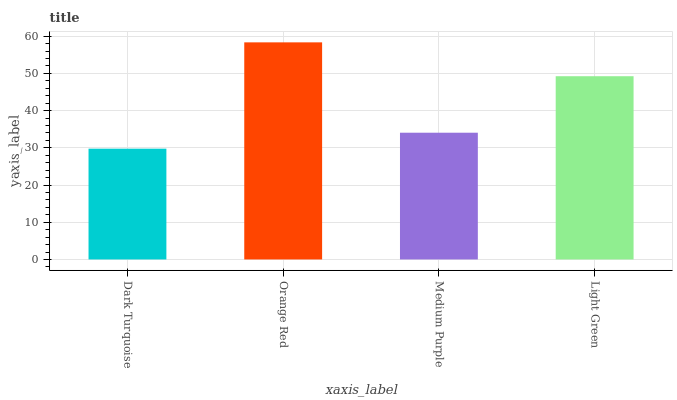Is Dark Turquoise the minimum?
Answer yes or no. Yes. Is Orange Red the maximum?
Answer yes or no. Yes. Is Medium Purple the minimum?
Answer yes or no. No. Is Medium Purple the maximum?
Answer yes or no. No. Is Orange Red greater than Medium Purple?
Answer yes or no. Yes. Is Medium Purple less than Orange Red?
Answer yes or no. Yes. Is Medium Purple greater than Orange Red?
Answer yes or no. No. Is Orange Red less than Medium Purple?
Answer yes or no. No. Is Light Green the high median?
Answer yes or no. Yes. Is Medium Purple the low median?
Answer yes or no. Yes. Is Dark Turquoise the high median?
Answer yes or no. No. Is Light Green the low median?
Answer yes or no. No. 